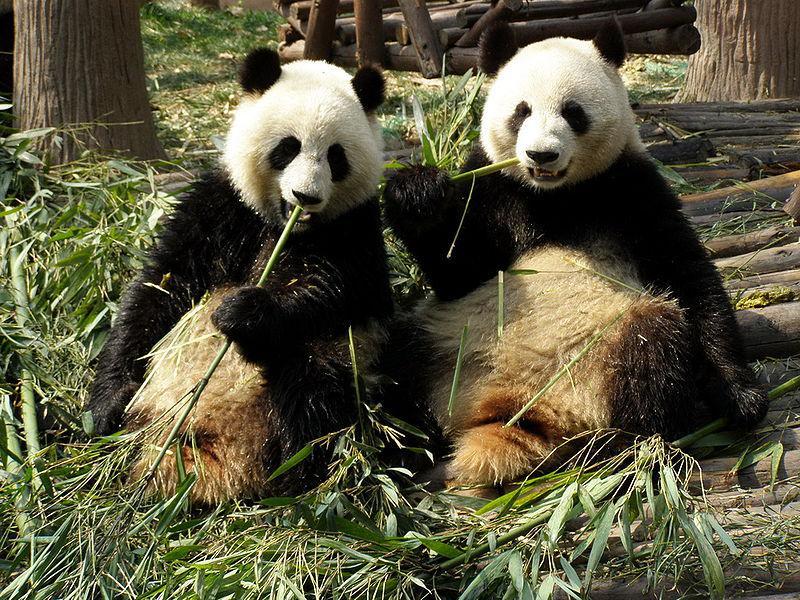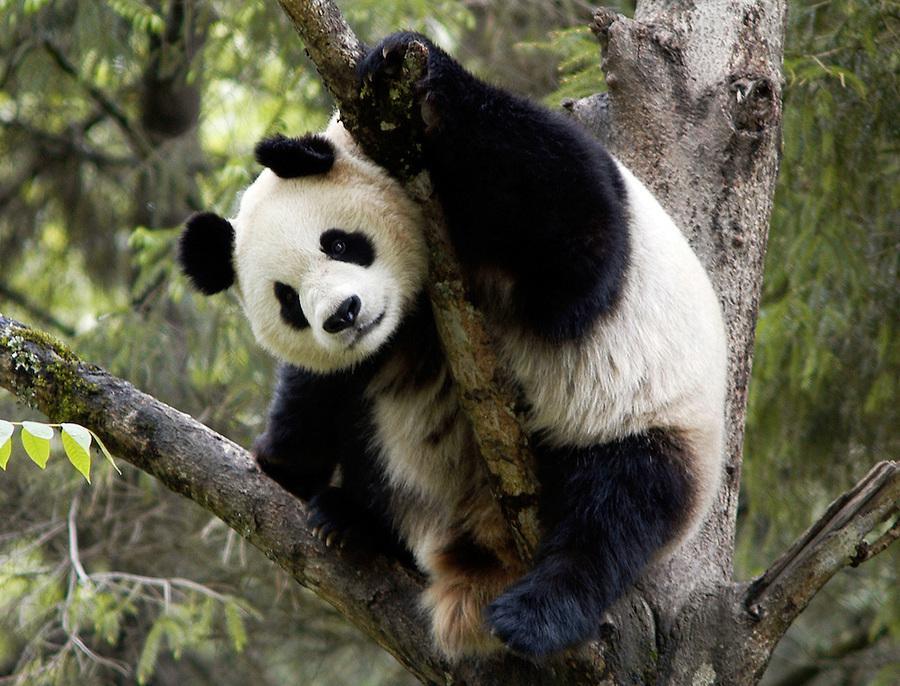The first image is the image on the left, the second image is the image on the right. For the images shown, is this caption "The left and right image contains the same number of pandas." true? Answer yes or no. No. The first image is the image on the left, the second image is the image on the right. For the images shown, is this caption "A panda is laying on its back." true? Answer yes or no. No. 